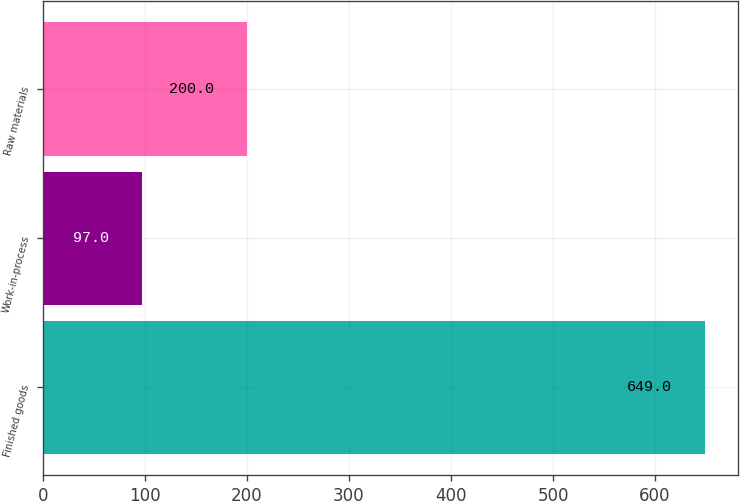<chart> <loc_0><loc_0><loc_500><loc_500><bar_chart><fcel>Finished goods<fcel>Work-in-process<fcel>Raw materials<nl><fcel>649<fcel>97<fcel>200<nl></chart> 